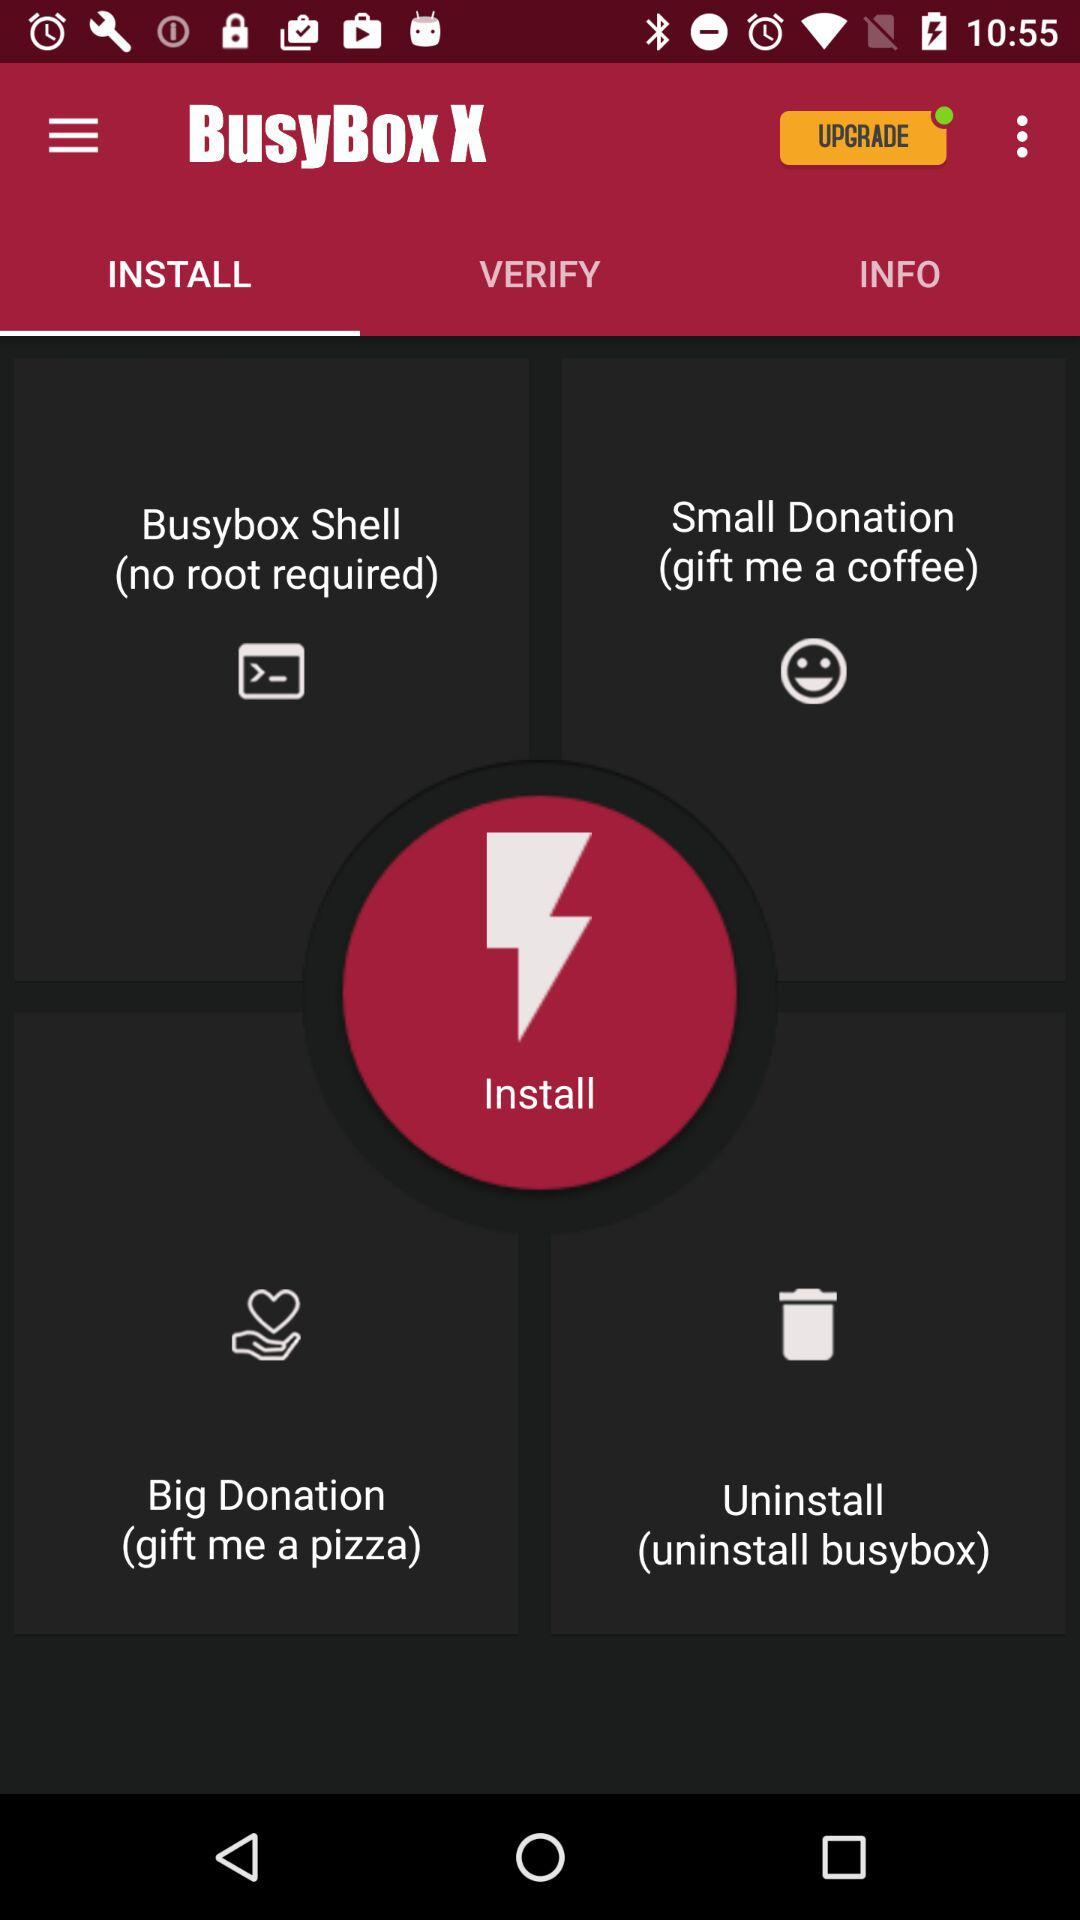What is the application name? The application name is "BusyBox X". 